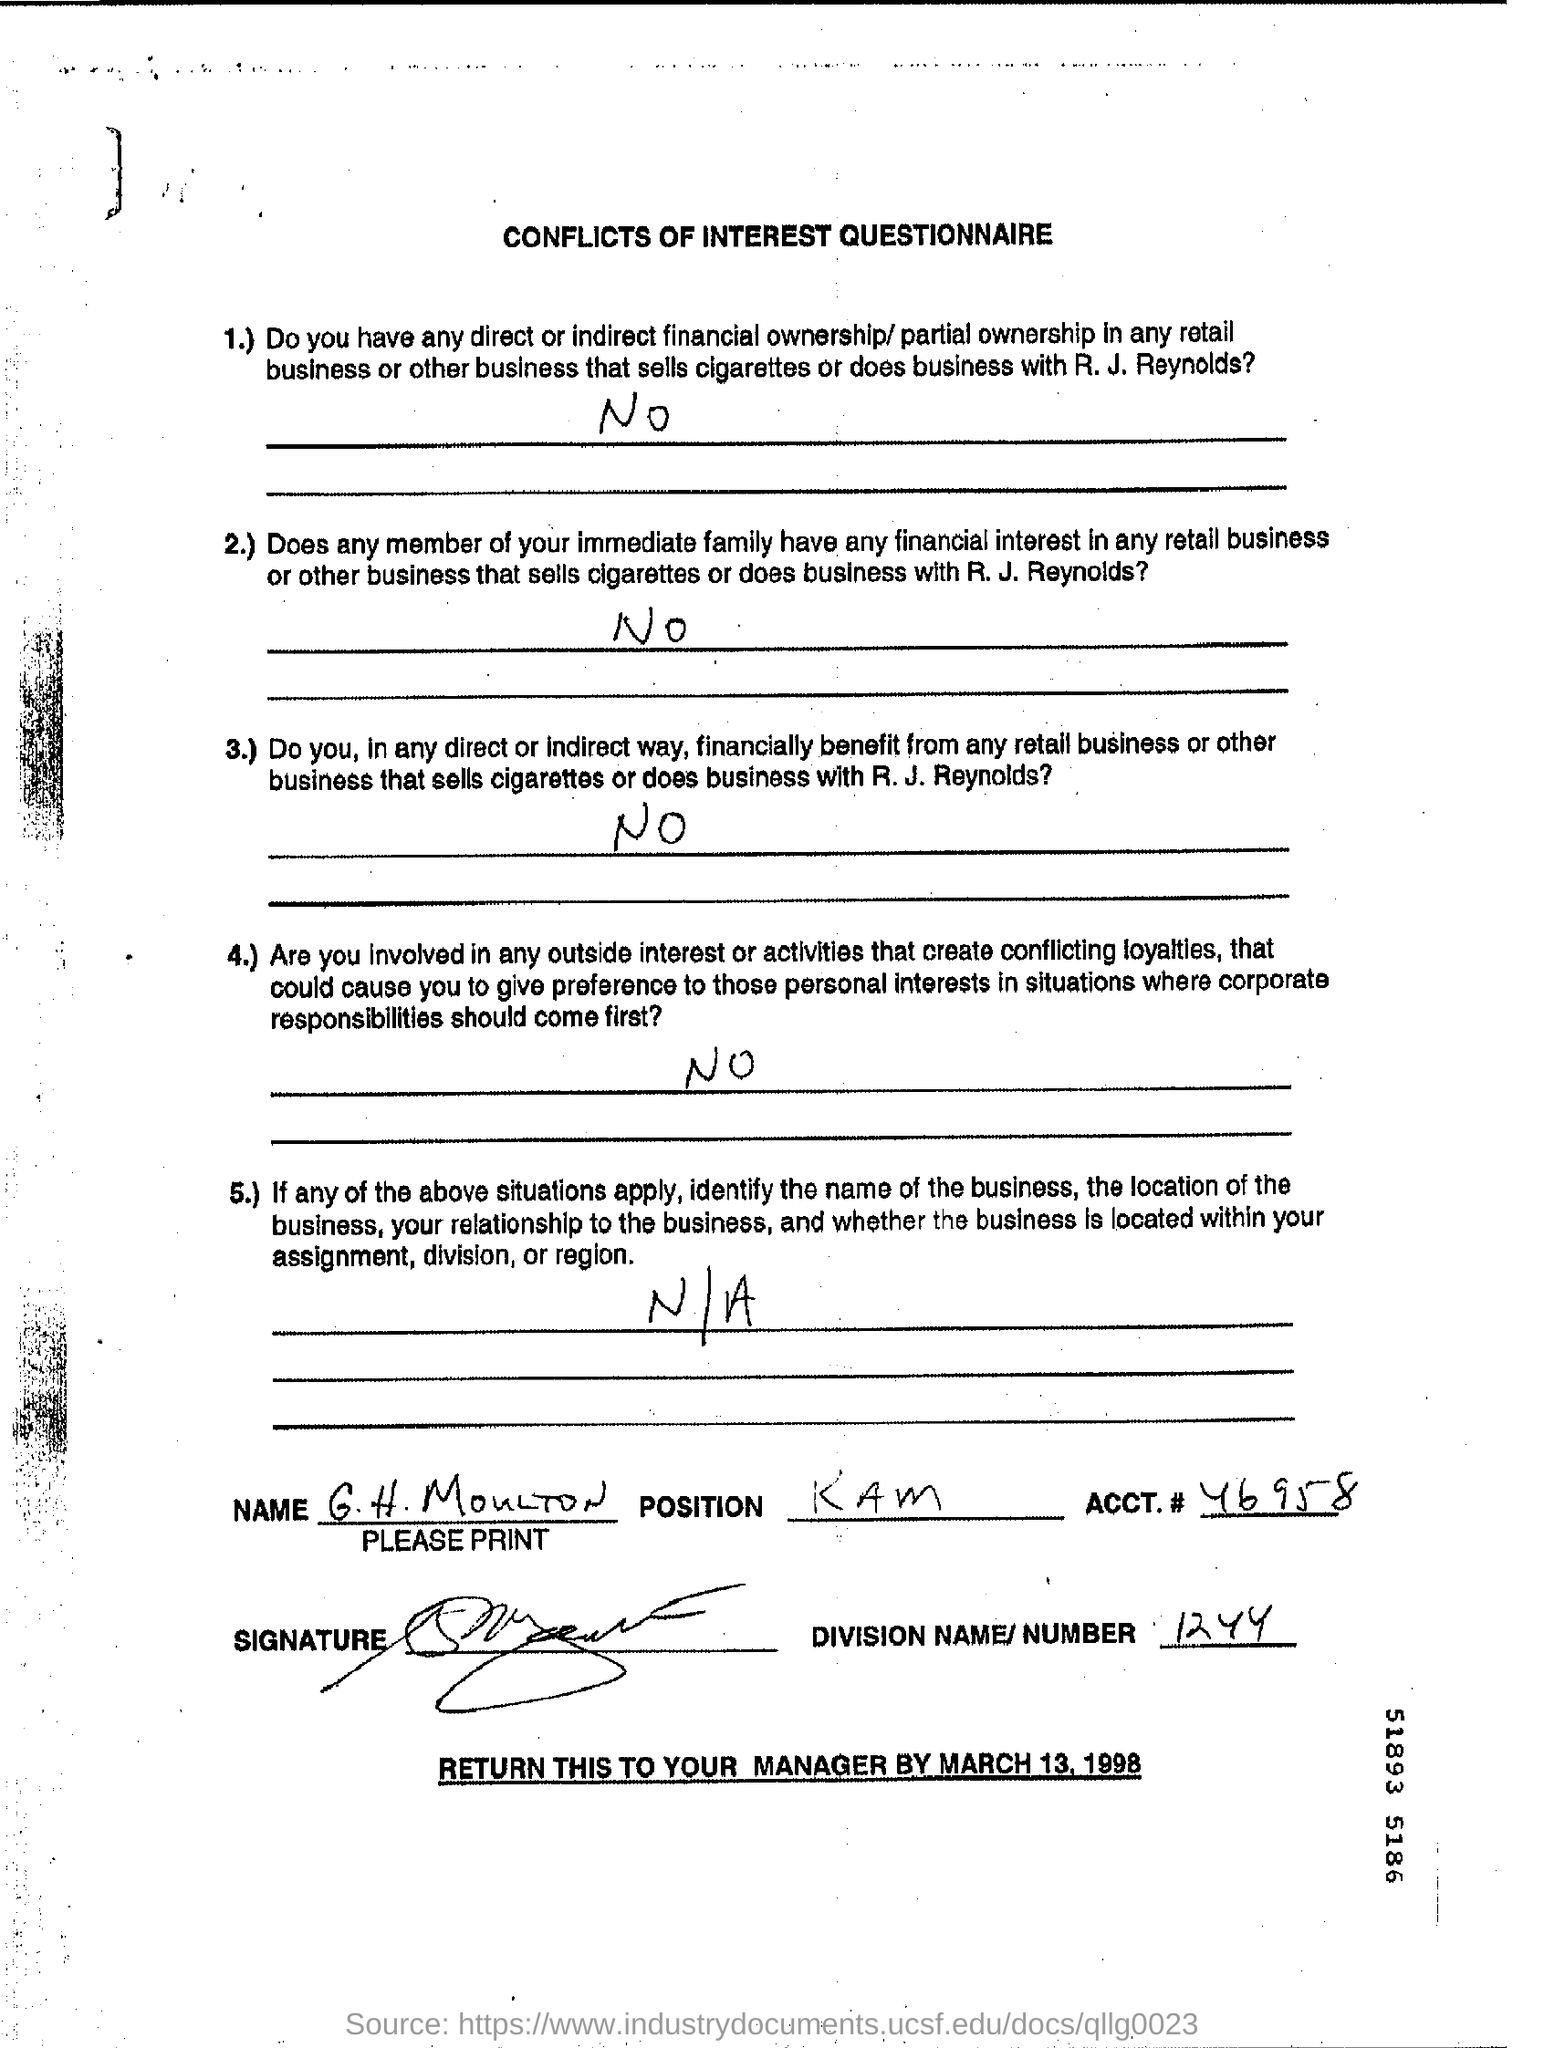Draw attention to some important aspects in this diagram. The division name/number is 1244... The ACCT number is 46958. 